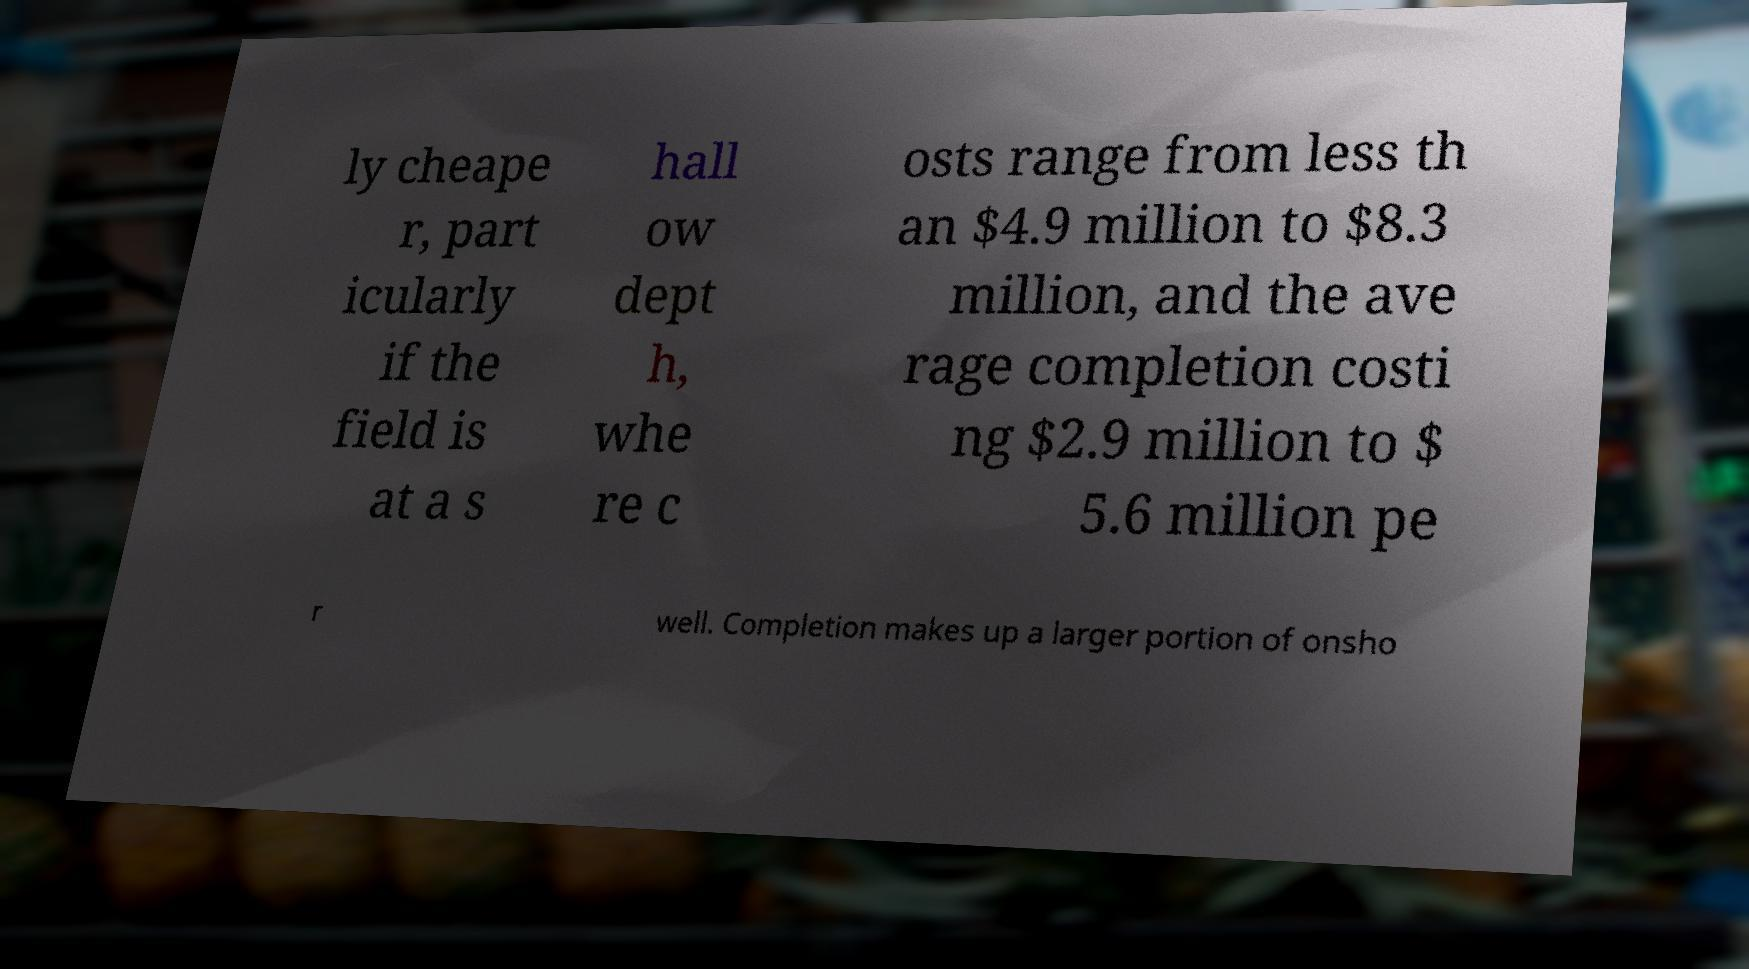I need the written content from this picture converted into text. Can you do that? ly cheape r, part icularly if the field is at a s hall ow dept h, whe re c osts range from less th an $4.9 million to $8.3 million, and the ave rage completion costi ng $2.9 million to $ 5.6 million pe r well. Completion makes up a larger portion of onsho 